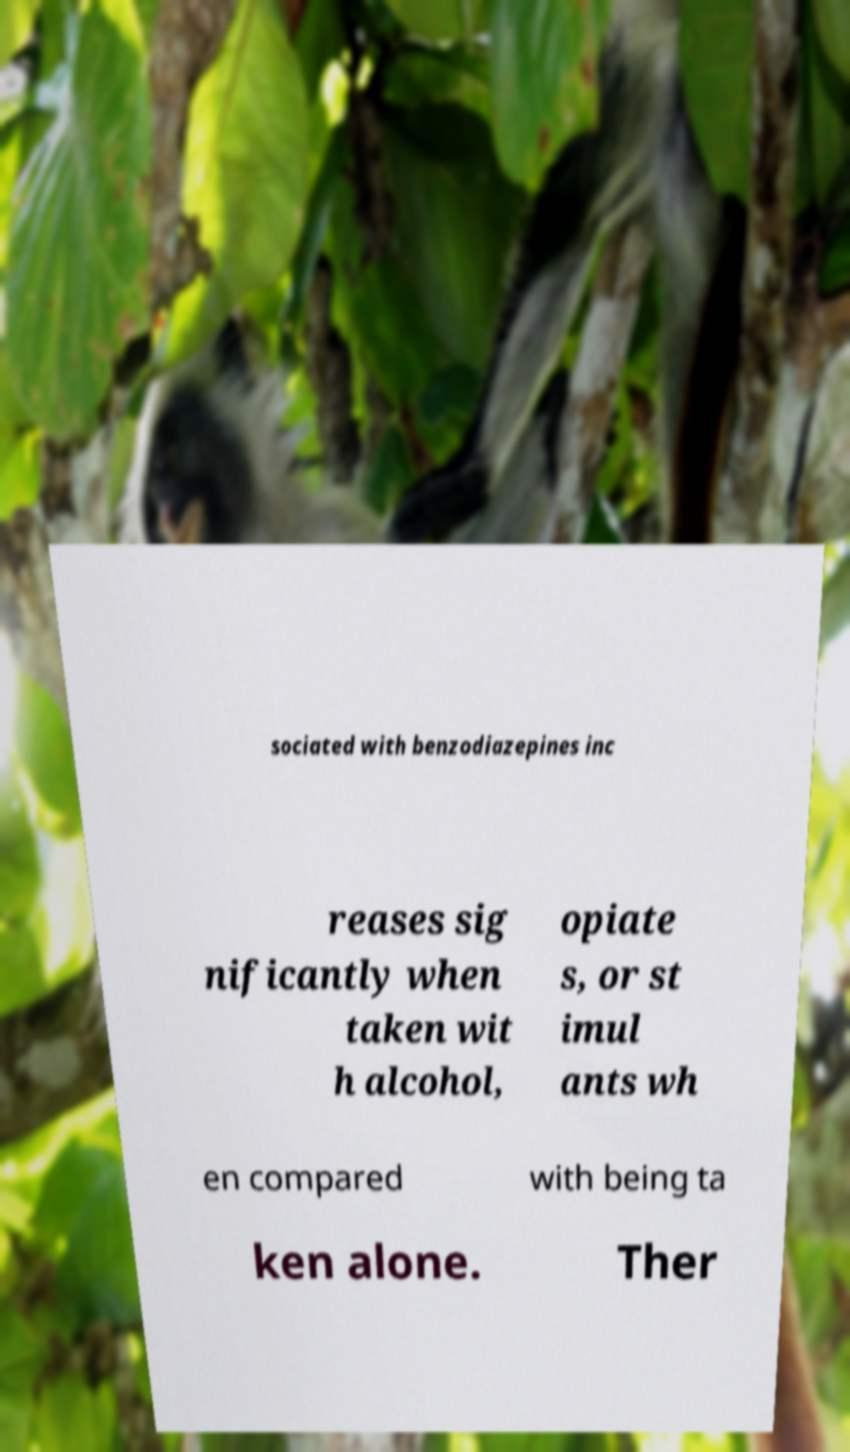Please identify and transcribe the text found in this image. sociated with benzodiazepines inc reases sig nificantly when taken wit h alcohol, opiate s, or st imul ants wh en compared with being ta ken alone. Ther 